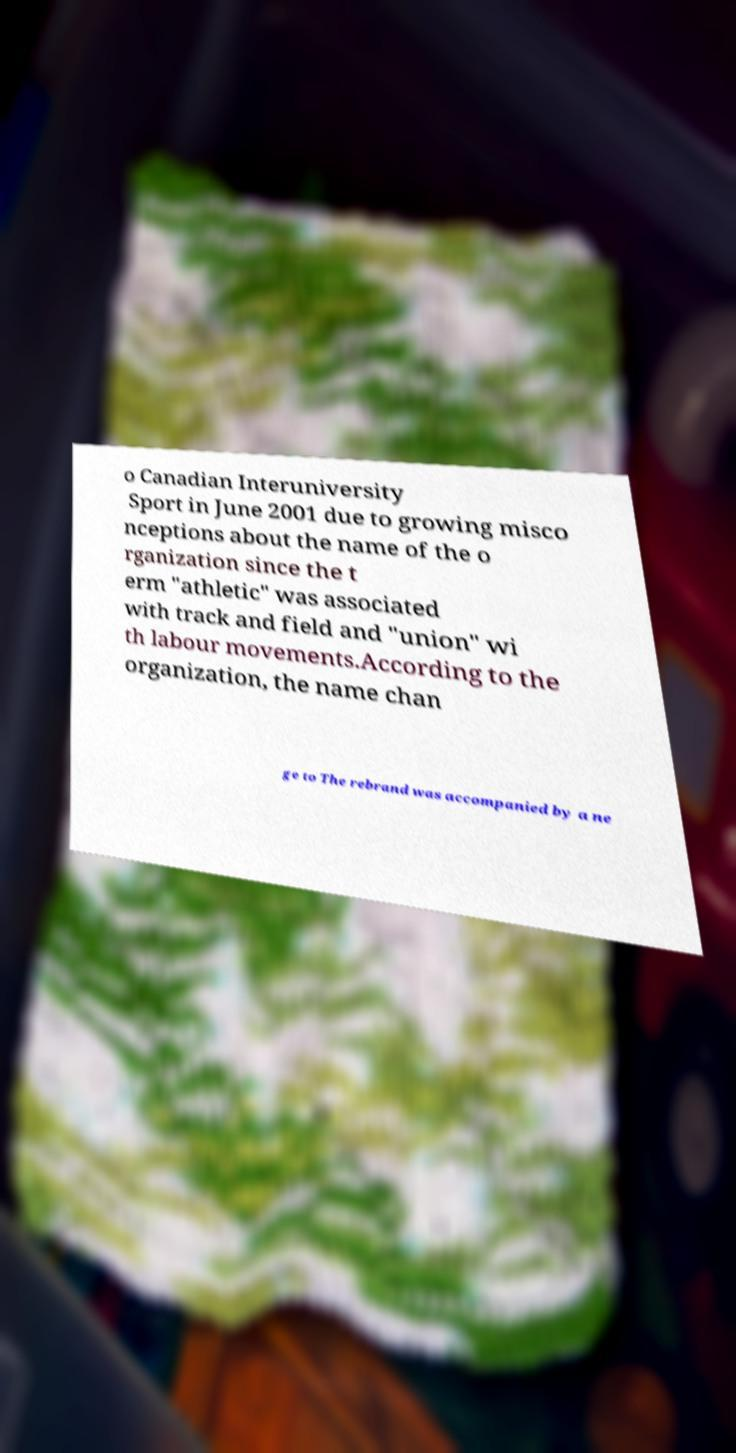For documentation purposes, I need the text within this image transcribed. Could you provide that? o Canadian Interuniversity Sport in June 2001 due to growing misco nceptions about the name of the o rganization since the t erm "athletic" was associated with track and field and "union" wi th labour movements.According to the organization, the name chan ge to The rebrand was accompanied by a ne 